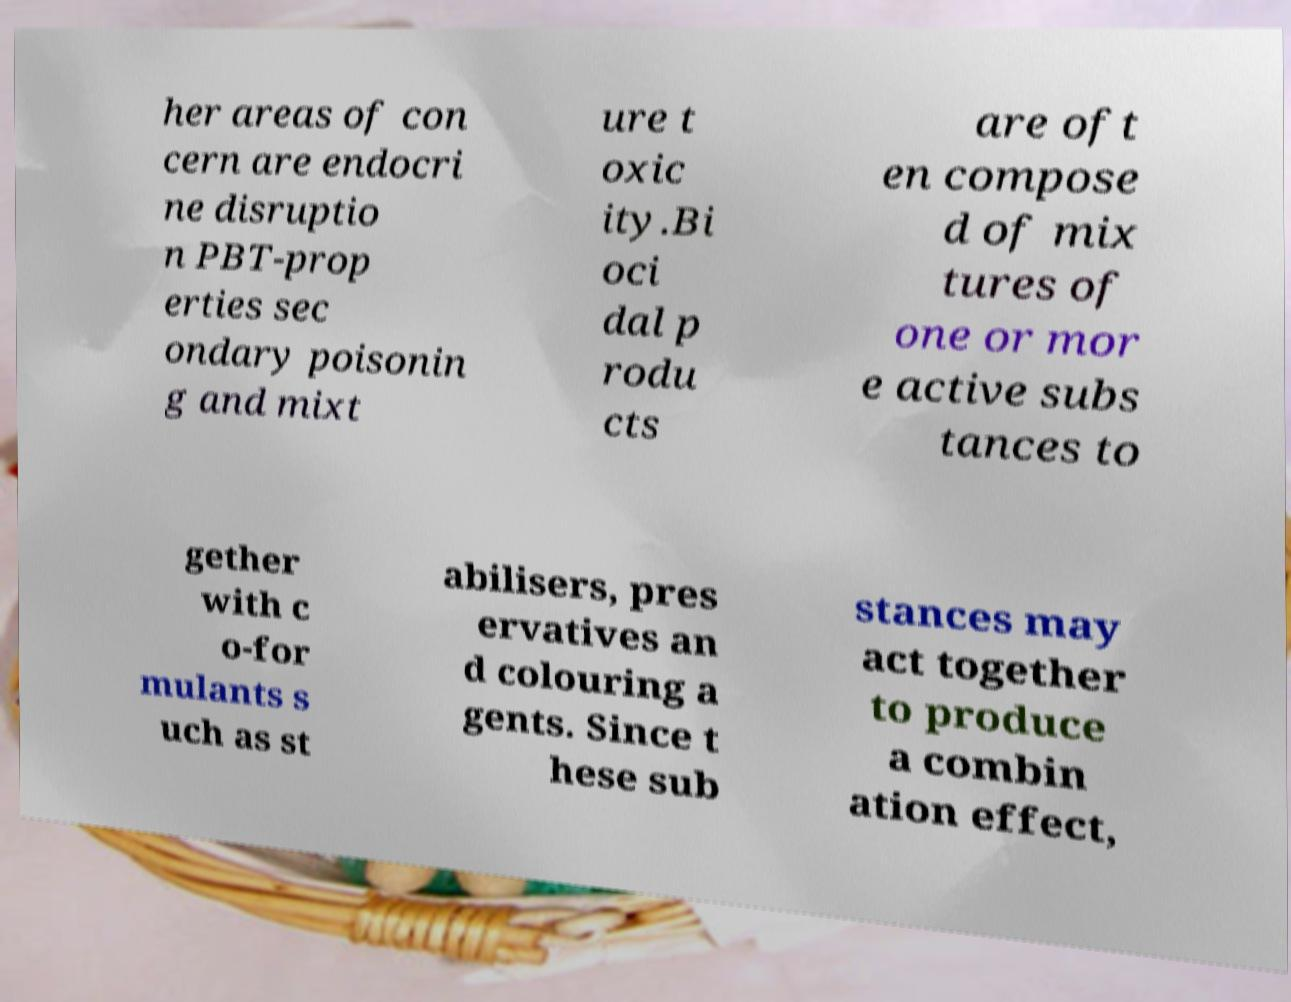I need the written content from this picture converted into text. Can you do that? her areas of con cern are endocri ne disruptio n PBT-prop erties sec ondary poisonin g and mixt ure t oxic ity.Bi oci dal p rodu cts are oft en compose d of mix tures of one or mor e active subs tances to gether with c o-for mulants s uch as st abilisers, pres ervatives an d colouring a gents. Since t hese sub stances may act together to produce a combin ation effect, 